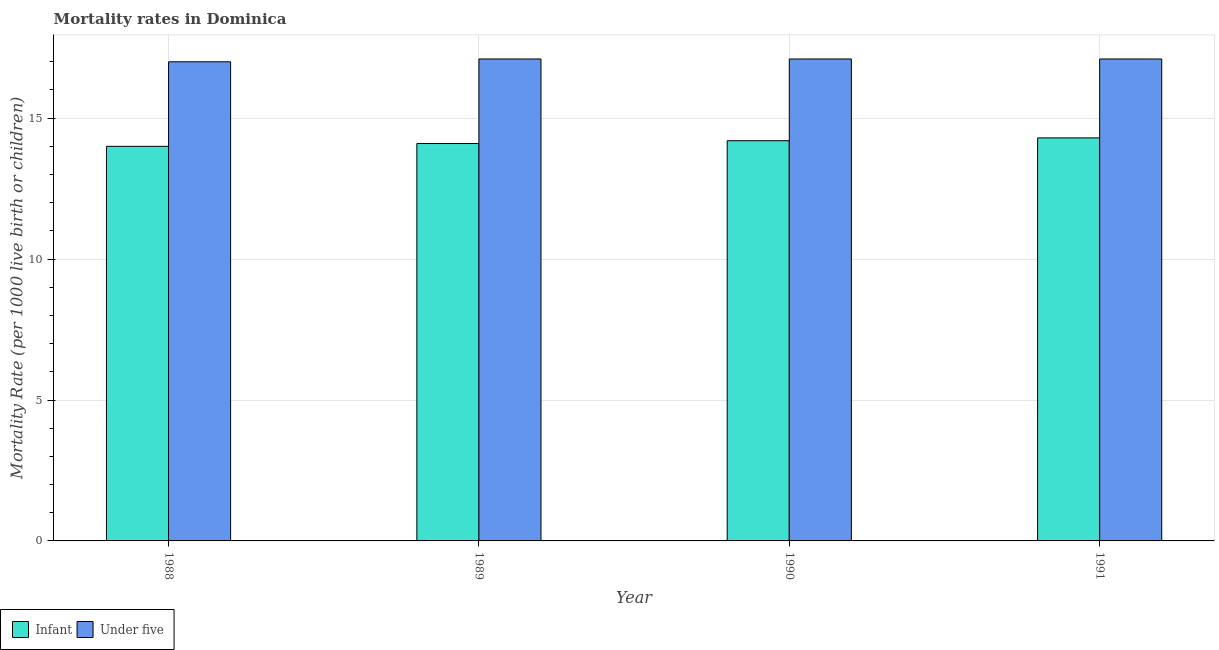How many different coloured bars are there?
Offer a terse response. 2. Are the number of bars per tick equal to the number of legend labels?
Your answer should be compact. Yes. How many bars are there on the 2nd tick from the left?
Your answer should be very brief. 2. How many bars are there on the 4th tick from the right?
Keep it short and to the point. 2. In how many cases, is the number of bars for a given year not equal to the number of legend labels?
Ensure brevity in your answer.  0. Across all years, what is the maximum infant mortality rate?
Provide a succinct answer. 14.3. Across all years, what is the minimum under-5 mortality rate?
Your answer should be compact. 17. In which year was the under-5 mortality rate maximum?
Give a very brief answer. 1989. In which year was the infant mortality rate minimum?
Make the answer very short. 1988. What is the total infant mortality rate in the graph?
Your response must be concise. 56.6. What is the difference between the under-5 mortality rate in 1988 and that in 1989?
Make the answer very short. -0.1. What is the difference between the infant mortality rate in 1990 and the under-5 mortality rate in 1988?
Make the answer very short. 0.2. What is the average under-5 mortality rate per year?
Give a very brief answer. 17.08. In how many years, is the infant mortality rate greater than 6?
Provide a short and direct response. 4. What is the ratio of the under-5 mortality rate in 1988 to that in 1991?
Your answer should be very brief. 0.99. What is the difference between the highest and the second highest infant mortality rate?
Your answer should be very brief. 0.1. What is the difference between the highest and the lowest infant mortality rate?
Ensure brevity in your answer.  0.3. Is the sum of the infant mortality rate in 1988 and 1990 greater than the maximum under-5 mortality rate across all years?
Offer a terse response. Yes. What does the 2nd bar from the left in 1990 represents?
Your answer should be compact. Under five. What does the 1st bar from the right in 1990 represents?
Ensure brevity in your answer.  Under five. Are all the bars in the graph horizontal?
Provide a succinct answer. No. How many years are there in the graph?
Your response must be concise. 4. Are the values on the major ticks of Y-axis written in scientific E-notation?
Give a very brief answer. No. Does the graph contain any zero values?
Ensure brevity in your answer.  No. Does the graph contain grids?
Your answer should be compact. Yes. Where does the legend appear in the graph?
Provide a succinct answer. Bottom left. How many legend labels are there?
Offer a very short reply. 2. How are the legend labels stacked?
Your answer should be compact. Horizontal. What is the title of the graph?
Offer a very short reply. Mortality rates in Dominica. What is the label or title of the X-axis?
Keep it short and to the point. Year. What is the label or title of the Y-axis?
Make the answer very short. Mortality Rate (per 1000 live birth or children). What is the Mortality Rate (per 1000 live birth or children) of Infant in 1988?
Make the answer very short. 14. What is the Mortality Rate (per 1000 live birth or children) in Under five in 1988?
Offer a very short reply. 17. What is the Mortality Rate (per 1000 live birth or children) of Infant in 1990?
Your response must be concise. 14.2. What is the Mortality Rate (per 1000 live birth or children) in Infant in 1991?
Give a very brief answer. 14.3. Across all years, what is the maximum Mortality Rate (per 1000 live birth or children) of Under five?
Offer a terse response. 17.1. Across all years, what is the minimum Mortality Rate (per 1000 live birth or children) of Under five?
Keep it short and to the point. 17. What is the total Mortality Rate (per 1000 live birth or children) of Infant in the graph?
Make the answer very short. 56.6. What is the total Mortality Rate (per 1000 live birth or children) in Under five in the graph?
Provide a succinct answer. 68.3. What is the difference between the Mortality Rate (per 1000 live birth or children) of Infant in 1988 and that in 1989?
Keep it short and to the point. -0.1. What is the difference between the Mortality Rate (per 1000 live birth or children) in Under five in 1988 and that in 1990?
Provide a succinct answer. -0.1. What is the difference between the Mortality Rate (per 1000 live birth or children) in Under five in 1988 and that in 1991?
Offer a terse response. -0.1. What is the difference between the Mortality Rate (per 1000 live birth or children) in Infant in 1989 and that in 1991?
Offer a terse response. -0.2. What is the difference between the Mortality Rate (per 1000 live birth or children) of Under five in 1989 and that in 1991?
Keep it short and to the point. 0. What is the difference between the Mortality Rate (per 1000 live birth or children) in Infant in 1988 and the Mortality Rate (per 1000 live birth or children) in Under five in 1990?
Offer a very short reply. -3.1. What is the difference between the Mortality Rate (per 1000 live birth or children) in Infant in 1989 and the Mortality Rate (per 1000 live birth or children) in Under five in 1990?
Provide a succinct answer. -3. What is the difference between the Mortality Rate (per 1000 live birth or children) of Infant in 1989 and the Mortality Rate (per 1000 live birth or children) of Under five in 1991?
Give a very brief answer. -3. What is the average Mortality Rate (per 1000 live birth or children) in Infant per year?
Provide a succinct answer. 14.15. What is the average Mortality Rate (per 1000 live birth or children) in Under five per year?
Provide a short and direct response. 17.07. In the year 1988, what is the difference between the Mortality Rate (per 1000 live birth or children) of Infant and Mortality Rate (per 1000 live birth or children) of Under five?
Ensure brevity in your answer.  -3. In the year 1989, what is the difference between the Mortality Rate (per 1000 live birth or children) in Infant and Mortality Rate (per 1000 live birth or children) in Under five?
Provide a succinct answer. -3. In the year 1990, what is the difference between the Mortality Rate (per 1000 live birth or children) in Infant and Mortality Rate (per 1000 live birth or children) in Under five?
Your answer should be compact. -2.9. In the year 1991, what is the difference between the Mortality Rate (per 1000 live birth or children) of Infant and Mortality Rate (per 1000 live birth or children) of Under five?
Your answer should be very brief. -2.8. What is the ratio of the Mortality Rate (per 1000 live birth or children) in Infant in 1988 to that in 1990?
Make the answer very short. 0.99. What is the ratio of the Mortality Rate (per 1000 live birth or children) in Infant in 1988 to that in 1991?
Your answer should be compact. 0.98. What is the ratio of the Mortality Rate (per 1000 live birth or children) in Infant in 1989 to that in 1990?
Your answer should be very brief. 0.99. What is the ratio of the Mortality Rate (per 1000 live birth or children) of Under five in 1989 to that in 1991?
Offer a terse response. 1. What is the ratio of the Mortality Rate (per 1000 live birth or children) of Infant in 1990 to that in 1991?
Offer a very short reply. 0.99. What is the ratio of the Mortality Rate (per 1000 live birth or children) in Under five in 1990 to that in 1991?
Give a very brief answer. 1. What is the difference between the highest and the second highest Mortality Rate (per 1000 live birth or children) of Infant?
Provide a short and direct response. 0.1. What is the difference between the highest and the lowest Mortality Rate (per 1000 live birth or children) in Under five?
Your response must be concise. 0.1. 